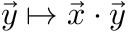<formula> <loc_0><loc_0><loc_500><loc_500>{ \vec { y } } \mapsto { \vec { x } } \cdot { \vec { y } }</formula> 